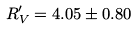<formula> <loc_0><loc_0><loc_500><loc_500>R _ { V } ^ { \prime } = 4 . 0 5 \pm 0 . 8 0</formula> 